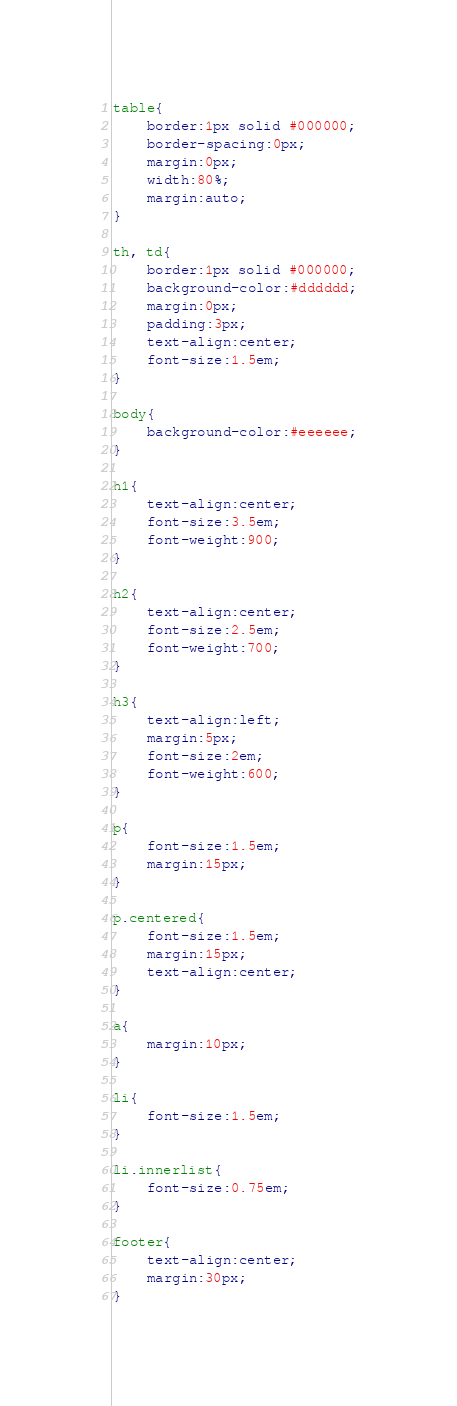Convert code to text. <code><loc_0><loc_0><loc_500><loc_500><_CSS_>table{
	border:1px solid #000000;
	border-spacing:0px;
	margin:0px;
	width:80%;
	margin:auto;
}

th, td{
	border:1px solid #000000;
	background-color:#dddddd;
	margin:0px;
	padding:3px;
	text-align:center;
	font-size:1.5em;
}

body{
	background-color:#eeeeee;
}

h1{
	text-align:center;
	font-size:3.5em;
	font-weight:900;
}

h2{
	text-align:center;
	font-size:2.5em;
	font-weight:700;
}

h3{
	text-align:left;
	margin:5px;
	font-size:2em;
	font-weight:600;
}

p{
	font-size:1.5em;
	margin:15px;
}

p.centered{
	font-size:1.5em;
	margin:15px;
	text-align:center;
}

a{
	margin:10px;
}

li{
	font-size:1.5em;
}

li.innerlist{
	font-size:0.75em;
}

footer{
	text-align:center;
	margin:30px;
}</code> 